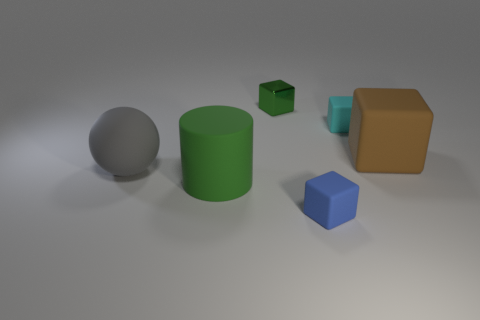Subtract all brown cubes. How many cubes are left? 3 Subtract all cyan blocks. How many blocks are left? 3 Subtract 4 blocks. How many blocks are left? 0 Subtract all blocks. How many objects are left? 2 Subtract all tiny green metal blocks. Subtract all tiny blue things. How many objects are left? 4 Add 1 large brown matte cubes. How many large brown matte cubes are left? 2 Add 3 large metallic objects. How many large metallic objects exist? 3 Add 1 small purple matte cubes. How many objects exist? 7 Subtract 0 purple blocks. How many objects are left? 6 Subtract all green spheres. Subtract all red cylinders. How many spheres are left? 1 